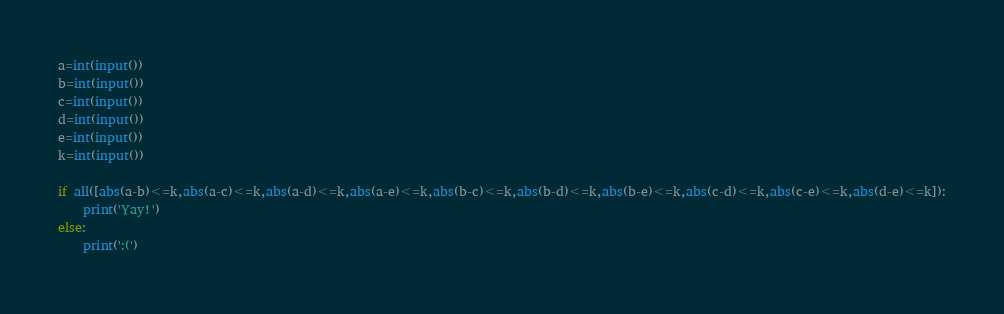<code> <loc_0><loc_0><loc_500><loc_500><_Python_>a=int(input())
b=int(input())
c=int(input())
d=int(input())
e=int(input())
k=int(input())

if all([abs(a-b)<=k,abs(a-c)<=k,abs(a-d)<=k,abs(a-e)<=k,abs(b-c)<=k,abs(b-d)<=k,abs(b-e)<=k,abs(c-d)<=k,abs(c-e)<=k,abs(d-e)<=k]):
    print('Yay!')
else:
    print(':(')</code> 